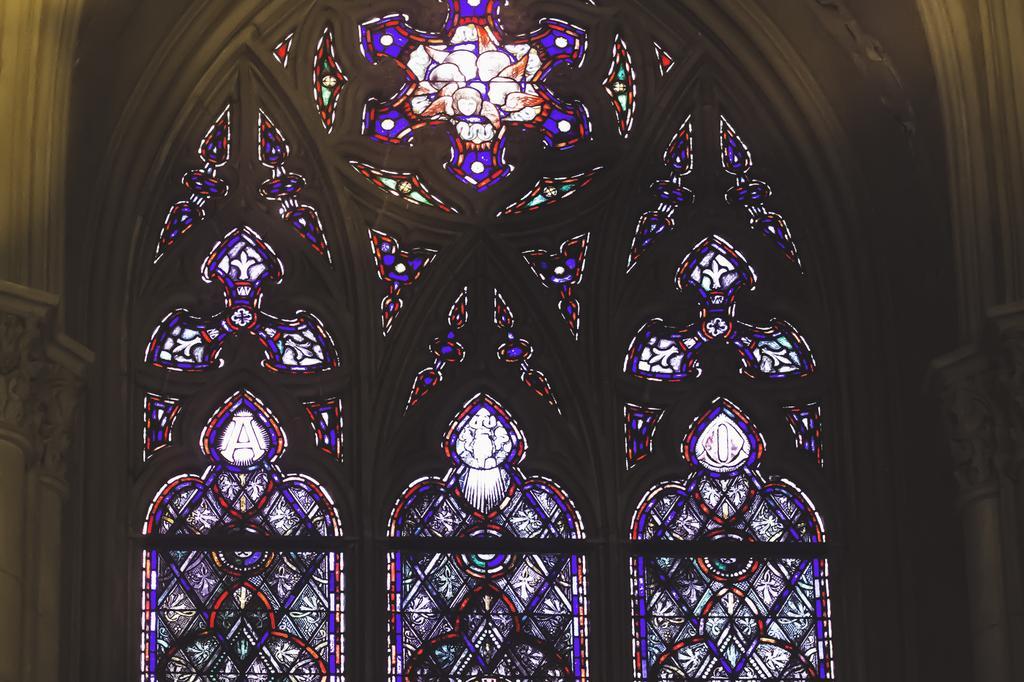Could you give a brief overview of what you see in this image? In this picture we can see a window with some painting on it and here it is a pillar where this is looking like an arch. 